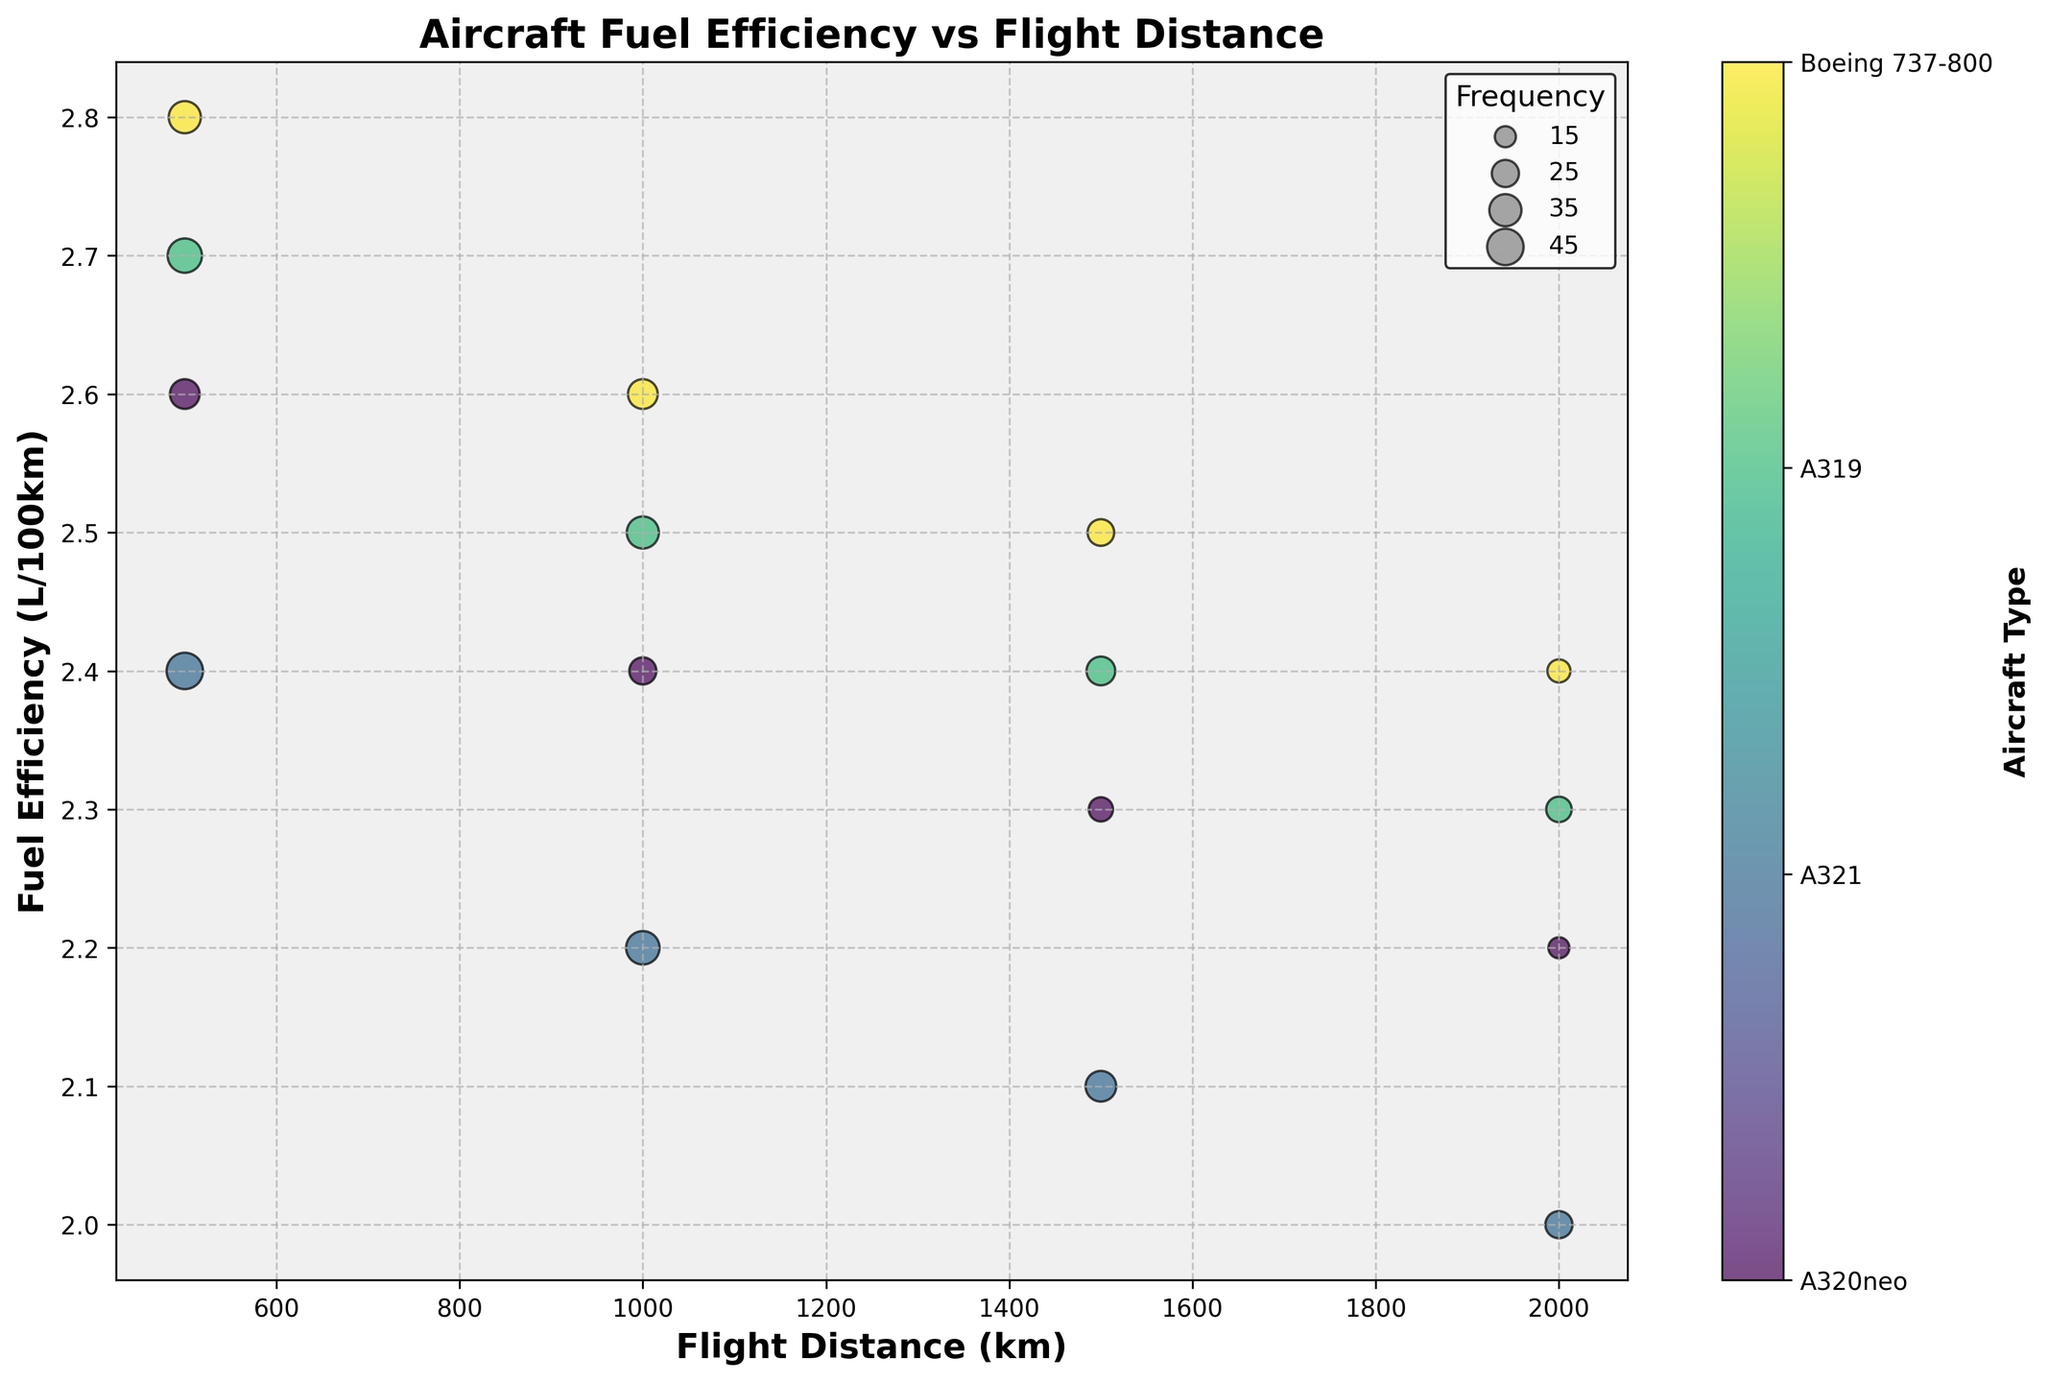What is the highest fuel efficiency observed for the A320neo aircraft? Look for the data points associated with the A320neo aircraft and identify the highest value on the y-axis (Fuel Efficiency). The highest y-value for A320neo is 2.0 L/100km at a flight distance of 2000 km.
Answer: 2.0 L/100km How does the fuel efficiency of the A321 change as the flight distance increases? Observe the trend of the A321 data points as you move from the left to the right on the x-axis (Flight Distance). The fuel efficiency (y-axis) of the A321 decreases from 2.7 L/100km at 500 km to 2.3 L/100km at 2000 km.
Answer: It decreases Which aircraft has the highest frequency for a flight distance of 1500 km? Compare the sizes of the data points at the 1500 km mark on the x-axis for each aircraft. The largest data point belongs to the A320neo with a frequency of 32.
Answer: A320neo What is the total frequency for all aircraft at a flight distance of 1000 km? Add the frequency values for all data points located at the 1000 km mark on the x-axis: 38 (A320neo) + 35 (A321) + 25 (A319) + 30 (Boeing 737-800). The total is 128.
Answer: 128 Which aircraft type shows the least variation in fuel efficiency across different flight distances? Compare the range of fuel efficiency values (y-axis) for each aircraft across the different flight distances. The A320neo varies from 2.4 to 2.0 L/100km, the A321 from 2.7 to 2.3, the A319 from 2.6 to 2.2, and the Boeing 737-800 from 2.8 to 2.4. The A320neo has the smallest range (0.4).
Answer: A320neo Which aircraft is more fuel-efficient at a flight distance of 500 km, the A320neo or the Boeing 737-800? Find the fuel efficiency values for these aircraft at 500 km on the x-axis. The A320neo has a fuel efficiency of 2.4 L/100km, and the Boeing 737-800 has 2.8 L/100km. The A320neo is more fuel-efficient.
Answer: A320neo Are there any aircraft that have the same fuel efficiency at any flight distance? Look for data points across the aircraft types that share the same y-axis value for any given x-axis value. The A321 and A319 both have a fuel efficiency of 2.4 L/100km at 1500 km.
Answer: Yes, the A321 and A319 at 1500 km What is the average fuel efficiency of the A319 across all flight distances? Calculate the average of the fuel efficiency values for the A319: (2.6 + 2.4 + 2.3 + 2.2) / 4 = 2.375 L/100km.
Answer: 2.375 L/100km Which flight distance has the highest total frequency across all aircraft? Sum the frequency values for each flight distance and compare. For 500 km: 45 + 40 + 30 + 35 = 150. For 1000 km: 38 + 35 + 25 + 30 = 128. For 1500 km: 32 + 28 + 20 + 24 = 104. For 2000 km: 25 + 22 + 15 + 18 = 80. The highest total frequency is at 500 km.
Answer: 500 km 